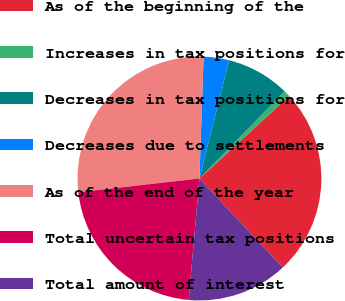<chart> <loc_0><loc_0><loc_500><loc_500><pie_chart><fcel>As of the beginning of the<fcel>Increases in tax positions for<fcel>Decreases in tax positions for<fcel>Decreases due to settlements<fcel>As of the end of the year<fcel>Total uncertain tax positions<fcel>Total amount of interest<nl><fcel>24.84%<fcel>0.87%<fcel>8.39%<fcel>3.38%<fcel>27.34%<fcel>21.79%<fcel>13.4%<nl></chart> 